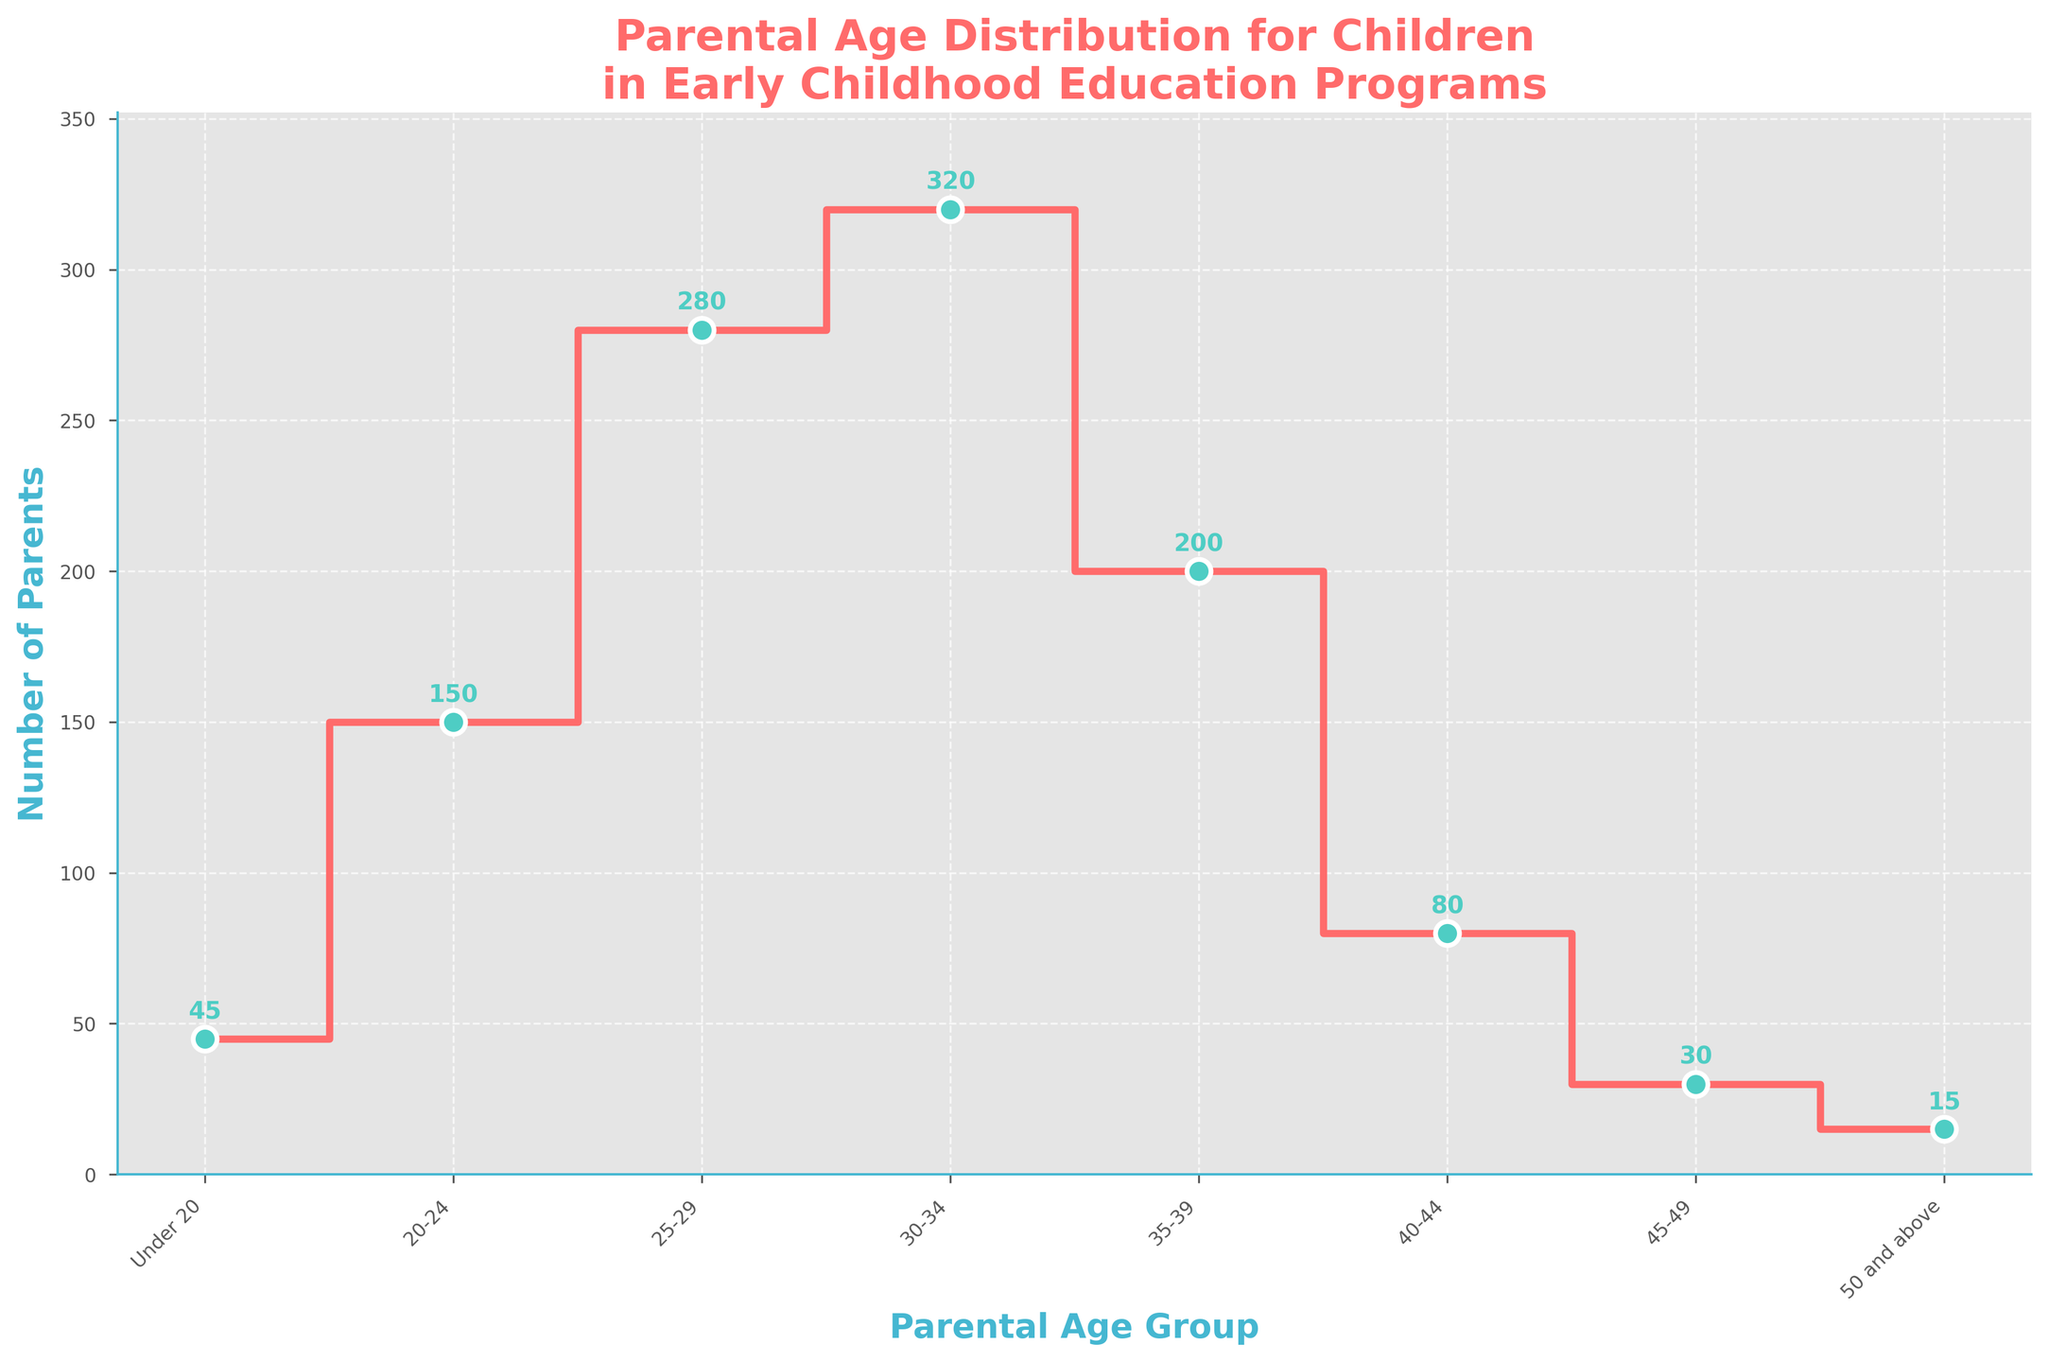What's the title of the plot? The title is displayed prominently at the top of the plot in a larger font, making it easy to identify.
Answer: Parental Age Distribution for Children in Early Childhood Education Programs What's the highest number of parents in any age group? To find this, observe the y-axis values at the highest point of the stair plot.
Answer: 320 How many age groups are represented in the figure? Count the distinct categories on the x-axis to determine the number of groups.
Answer: 8 Which parental age group has the fewest parents? Find the age group with the lowest y-value on the plot.
Answer: 50 and above How many parents are there between the ages of 30 and 39? Add the number of parents in the 30-34 and 35-39 age groups. 320 (30-34) + 200 (35-39) = 520
Answer: 520 Which parental age group has more parents, 20-24 or 35-39? Compare the y-values for the 20-24 and 35-39 age groups. 150 (20-24) vs 200 (35-39)
Answer: 35-39 What is the sum of parents in the 25-29 and 30-34 age groups? Add the values for the 25-29 and 30-34 age groups. 280 (25-29) + 320 (30-34) = 600
Answer: 600 Are there more parents aged under 20 or aged 45 and above? Compare the totals for "Under 20" with "45-49" plus "50 and above". 45 (Under 20) vs 30 (45-49) + 15 (50 and above) = 45
Answer: Equal What's the difference in the number of parents between the 40-44 and the 25-29 age groups? Subtract the 25-29 group's parents from the 40-44 group's parents. 80 (40-44) - 280 (25-29) = -200
Answer: -200 